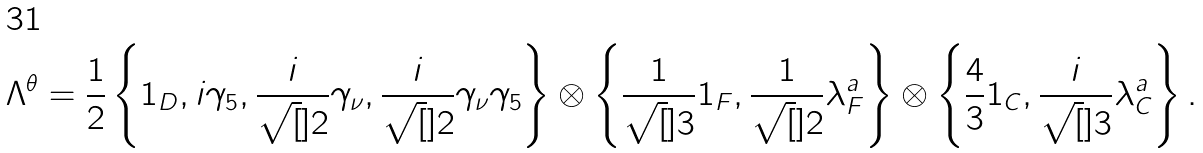<formula> <loc_0><loc_0><loc_500><loc_500>\Lambda ^ { \theta } = \frac { 1 } { 2 } \left \{ 1 _ { D } , i \gamma _ { 5 } , \frac { i } { \sqrt { [ } ] { 2 } } \gamma _ { \nu } , \frac { i } { \sqrt { [ } ] { 2 } } \gamma _ { \nu } \gamma _ { 5 } \right \} \otimes \left \{ \frac { 1 } { \sqrt { [ } ] { 3 } } 1 _ { F } , \frac { 1 } { \sqrt { [ } ] { 2 } } \lambda ^ { a } _ { F } \right \} \otimes \left \{ \frac { 4 } { 3 } 1 _ { C } , \frac { i } { \sqrt { [ } ] { 3 } } \lambda ^ { a } _ { C } \right \} .</formula> 